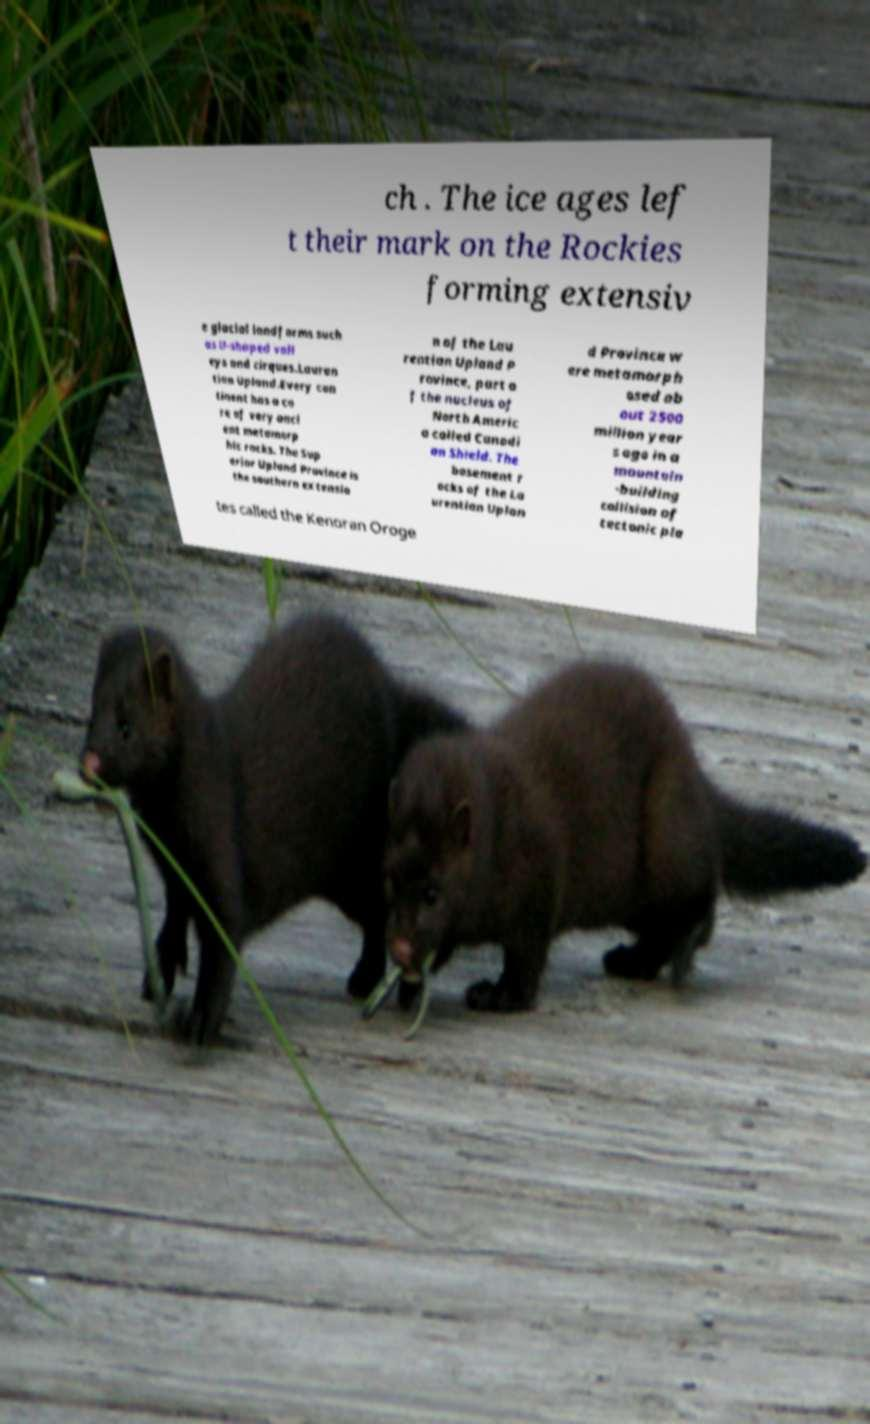I need the written content from this picture converted into text. Can you do that? ch . The ice ages lef t their mark on the Rockies forming extensiv e glacial landforms such as U-shaped vall eys and cirques.Lauren tian Upland.Every con tinent has a co re of very anci ent metamorp hic rocks. The Sup erior Upland Province is the southern extensio n of the Lau rentian Upland P rovince, part o f the nucleus of North Americ a called Canadi an Shield. The basement r ocks of the La urentian Uplan d Province w ere metamorph osed ab out 2500 million year s ago in a mountain -building collision of tectonic pla tes called the Kenoran Oroge 